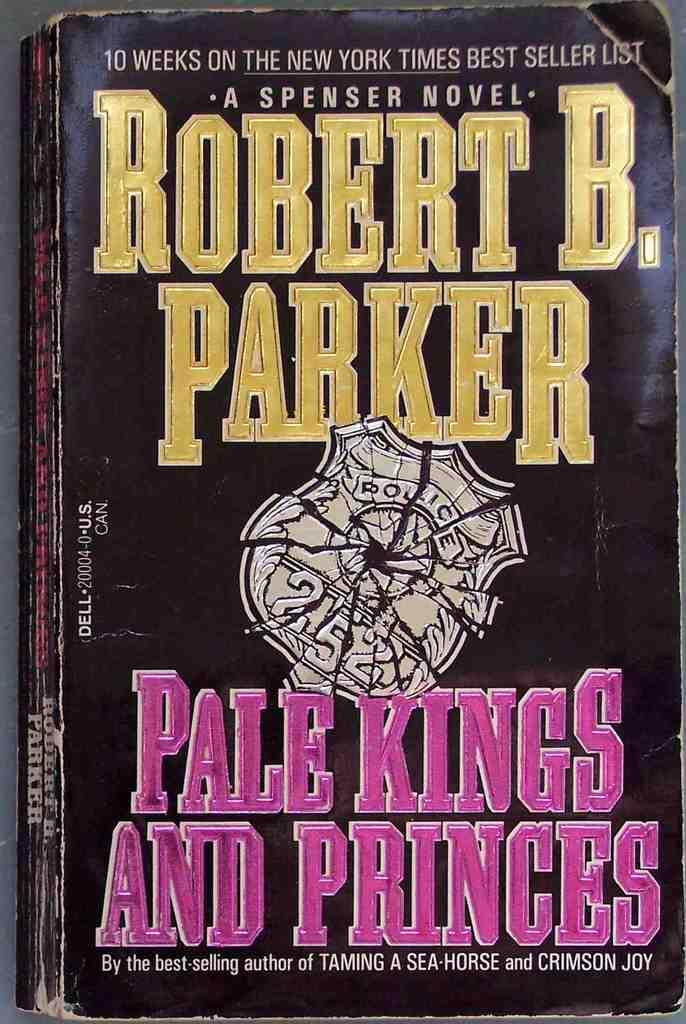<image>
Summarize the visual content of the image. The cover of the Pale Kings and Princes novel by Robert B. Parker includes a shattered police badge. 